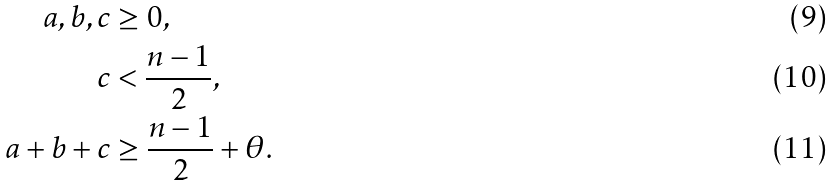<formula> <loc_0><loc_0><loc_500><loc_500>a , b , c & \geq 0 , \\ c & < \frac { n - 1 } { 2 } , \\ a + b + c & \geq \frac { n - 1 } { 2 } + \theta .</formula> 